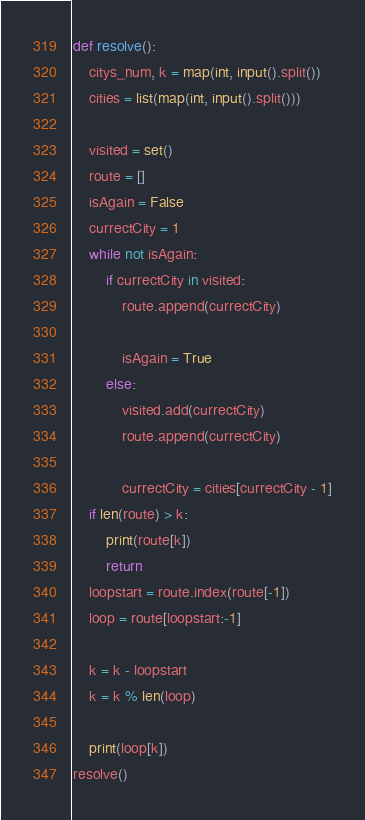Convert code to text. <code><loc_0><loc_0><loc_500><loc_500><_Python_>def resolve():
    citys_num, k = map(int, input().split())
    cities = list(map(int, input().split()))

    visited = set()
    route = []
    isAgain = False
    currectCity = 1
    while not isAgain:
        if currectCity in visited:
            route.append(currectCity)

            isAgain = True
        else:
            visited.add(currectCity)
            route.append(currectCity)

            currectCity = cities[currectCity - 1]
    if len(route) > k:
        print(route[k])
        return
    loopstart = route.index(route[-1])
    loop = route[loopstart:-1]

    k = k - loopstart
    k = k % len(loop)

    print(loop[k])
resolve()</code> 